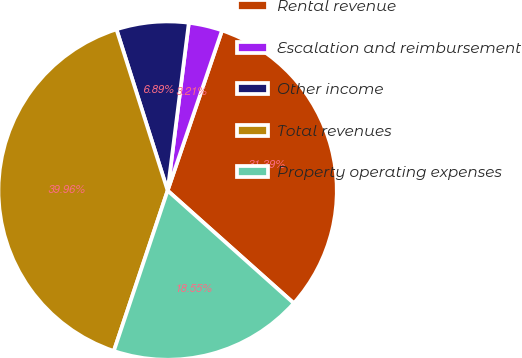Convert chart to OTSL. <chart><loc_0><loc_0><loc_500><loc_500><pie_chart><fcel>Rental revenue<fcel>Escalation and reimbursement<fcel>Other income<fcel>Total revenues<fcel>Property operating expenses<nl><fcel>31.39%<fcel>3.21%<fcel>6.89%<fcel>39.96%<fcel>18.55%<nl></chart> 